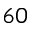<formula> <loc_0><loc_0><loc_500><loc_500>6 0</formula> 